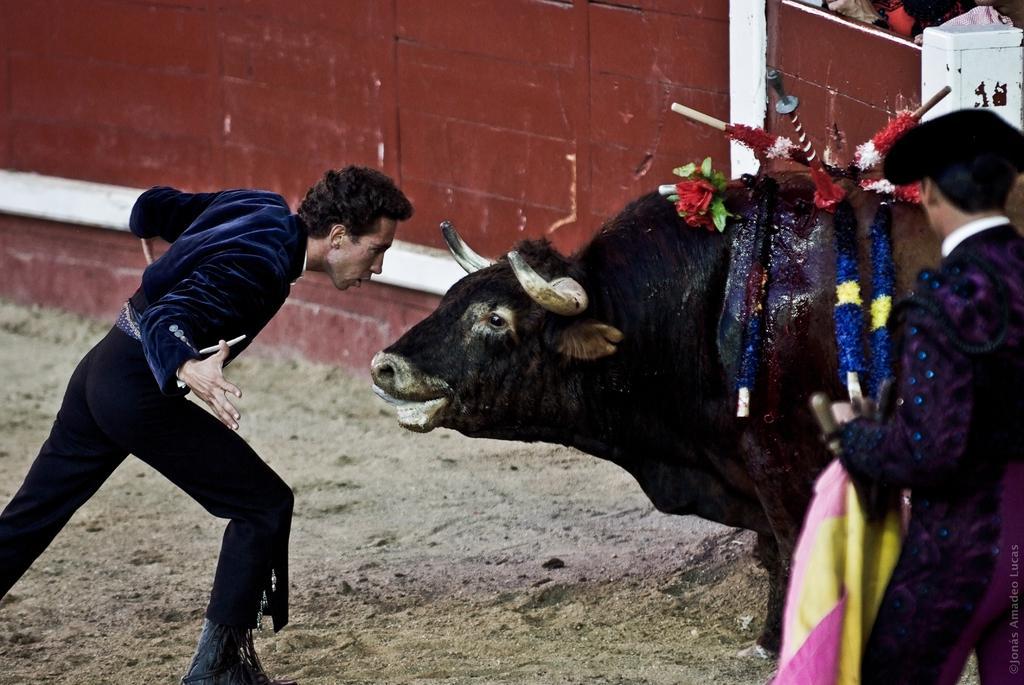Please provide a concise description of this image. In the image there is a person in navy blue dress standing in front of a bull with garlands above it and another person standing on the right side, in the back there is a fence. this is bull fight. 